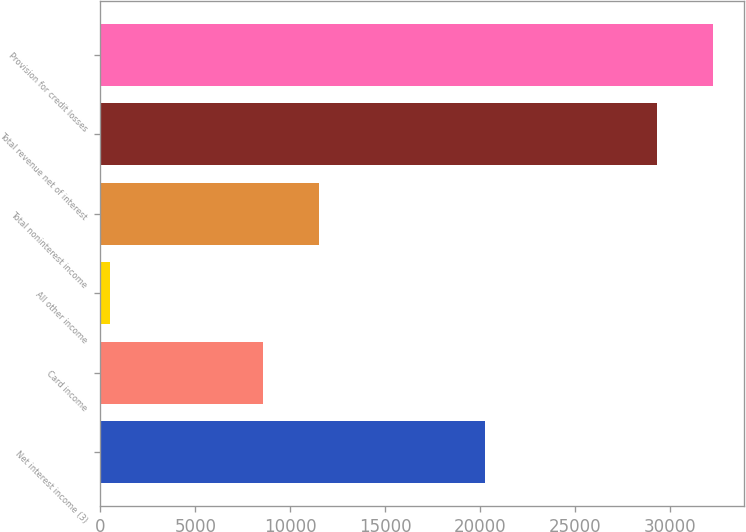<chart> <loc_0><loc_0><loc_500><loc_500><bar_chart><fcel>Net interest income (3)<fcel>Card income<fcel>All other income<fcel>Total noninterest income<fcel>Total revenue net of interest<fcel>Provision for credit losses<nl><fcel>20264<fcel>8555<fcel>523<fcel>11510.8<fcel>29342<fcel>32297.8<nl></chart> 